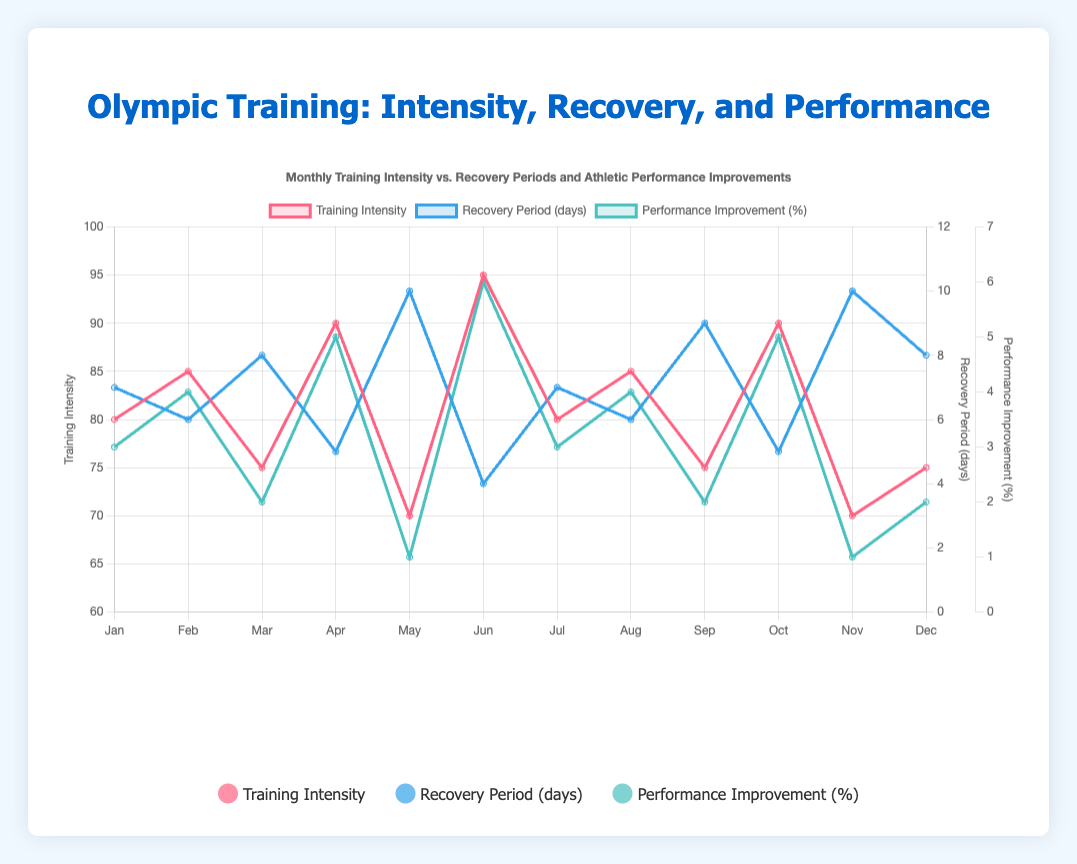Which month had the highest training intensity? By looking at the graph, we can see which line representing training intensity (red) reaches the highest peak. The peak occurs in June.
Answer: June How many months had a recovery period of exactly 10 days? We can count the number of points in the blue line (representing recovery periods) that are positioned at 10 on the y-axis. These points occur in May and November.
Answer: 2 What is the average performance improvement percentage for the months with a training intensity above 85? Identify which months have training intensities of 90 and 95 (April, June, and October). The performance improvements in these months are 5%, 6%, and 5%. The average is (5 + 6 + 5)/3.
Answer: 5.33% Which month had the longest recovery period but the lowest performance improvement percentage? By looking for the highest point on the blue line and the lowest point on the green line in the same month, we find that May had both the longest recovery period (10 days) and the lowest performance improvement (1%).
Answer: May Is there a noticeable pattern between training intensity and performance improvement? We can observe from the graph that generally, months with higher training intensity (values closer to 90 and 95) correspond to higher performance improvements (green line peaks), while lower intensity corresponds to lower improvements.
Answer: Yes, a higher training intensity often correlates with higher performance improvement What are the two months with equal training intensity and recovery period? Find the months where both the red and blue lines intersect at similar values. January and July both have a training intensity of 80 and a recovery period of 7 days.
Answer: January and July Which month had the steepest rise in training intensity compared to the previous month? Look for the largest positive slope between two consecutive points on the red line. The greatest increase occurs from May (70) to June (95), a difference of 25.
Answer: June During which months does the recovery period decrease yet performance improvement increases? Look for contrasting trends where the blue line decreases while the green line increases. Examples include April and October, where the recovery period decreases from March and September, respectively, yet performance improvement increases from the previous months.
Answer: April and October 